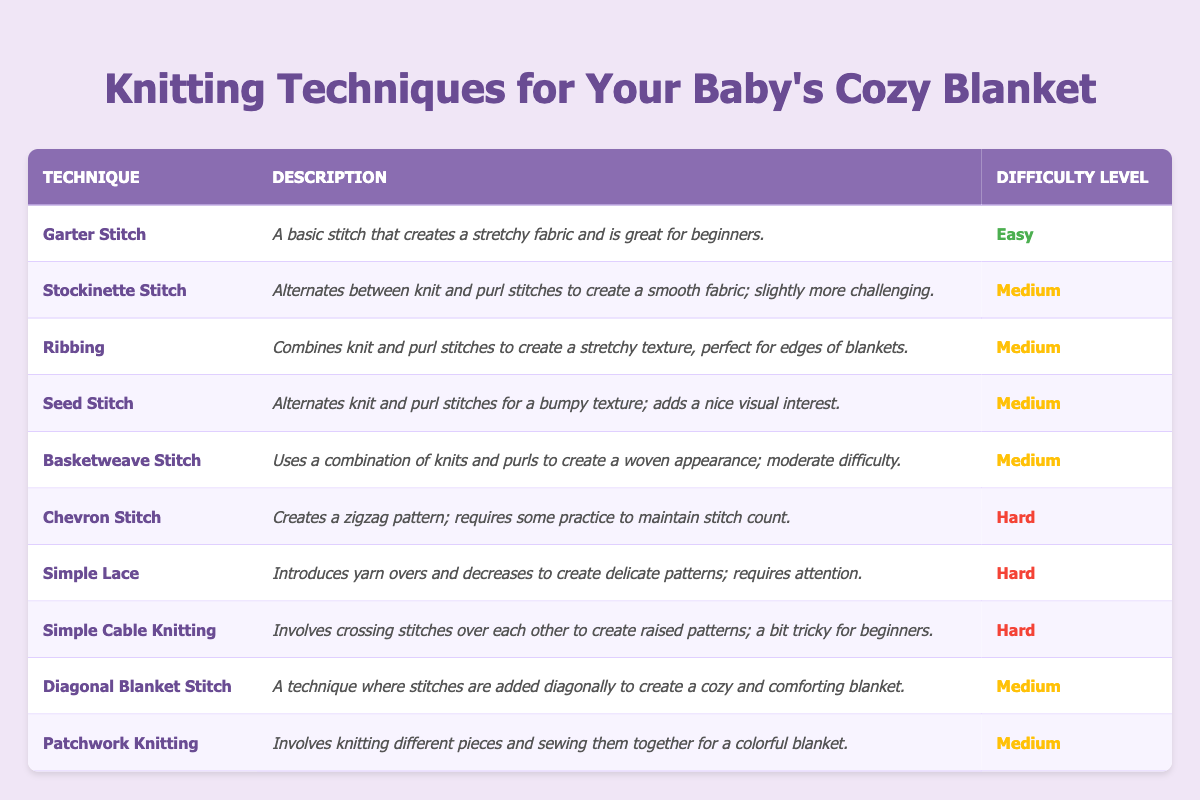What is the easiest knitting technique listed in the table? The table mentions multiple techniques, and "Garter Stitch" is indicated as "Easy" under the difficulty level column.
Answer: Garter Stitch How many knitting techniques have a medium difficulty level? By counting the techniques labeled as "Medium," we find there are six techniques: Stockinette Stitch, Ribbing, Seed Stitch, Basketweave Stitch, Diagonal Blanket Stitch, and Patchwork Knitting.
Answer: 6 Is "Simple Cable Knitting" classified as a medium difficulty technique? According to the difficulty level column in the table, "Simple Cable Knitting" is classified as "Hard," not "Medium."
Answer: No Which knitting technique creates a zigzag pattern? The technique "Chevron Stitch" is mentioned in the table, specifically stating that it creates a zigzag pattern.
Answer: Chevron Stitch What is the relationship between the difficulty level and the pattern type for "Simple Lace"? "Simple Lace" has a difficulty level of "Hard" and involves introducing yarn overs and decreases, which implies that it produces delicate patterns that take more skill to master than easier techniques.
Answer: Hard difficulty, delicate patterns How many techniques require practice to maintain stitch count? The table shows that only "Chevron Stitch" is noted as requiring practice to maintain stitch count, so that would be only one technique.
Answer: 1 Is "Seed Stitch" easier than "Basketweave Stitch"? Both techniques are listed with a medium difficulty level in the table, meaning they are equally challenging and not directly easier or harder than one another.
Answer: No Which techniques are recommended for the edges of blankets? The table indicates that "Ribbing" is perfect for edges of blankets due to its stretchy texture, and it's classified as medium difficulty.
Answer: Ribbing What is the total number of techniques that are categorized as hard? By reviewing the table, the hard techniques are "Chevron Stitch," "Simple Lace," and "Simple Cable Knitting," totaling three techniques classified as hard.
Answer: 3 What is the most difficult technique, and what does it entail? The most difficult techniques are identified as "Chevron Stitch," "Simple Lace," and "Simple Cable Knitting," all classified as "Hard." Each entails maintaining stitch counts, yarn overs, and crossing stitches, respectively.
Answer: Chevron Stitch, Simple Lace, Simple Cable Knitting 